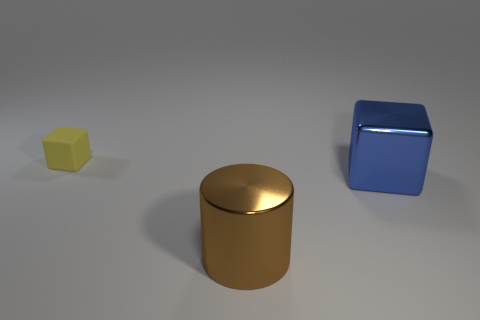Are there any other things that are the same size as the rubber cube?
Your answer should be compact. No. Is there anything else that has the same material as the tiny cube?
Make the answer very short. No. Do the object in front of the big blue cube and the yellow object have the same material?
Offer a terse response. No. What number of other objects are there of the same material as the small yellow cube?
Provide a short and direct response. 0. How many objects are objects on the left side of the brown metal cylinder or blocks right of the large brown cylinder?
Provide a short and direct response. 2. Do the small matte object that is behind the big blue cube and the thing right of the cylinder have the same shape?
Provide a succinct answer. Yes. What shape is the other metal thing that is the same size as the brown thing?
Your response must be concise. Cube. How many metal things are big cylinders or blue objects?
Your answer should be compact. 2. Does the block that is in front of the tiny matte block have the same material as the object that is behind the large metallic cube?
Give a very brief answer. No. What is the color of the big block that is the same material as the large cylinder?
Give a very brief answer. Blue. 